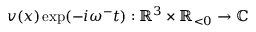<formula> <loc_0><loc_0><loc_500><loc_500>v ( x ) \exp ( - i \omega ^ { - } t ) \colon \mathbb { R } ^ { 3 } \times \mathbb { R } _ { < 0 } \rightarrow \mathbb { C }</formula> 